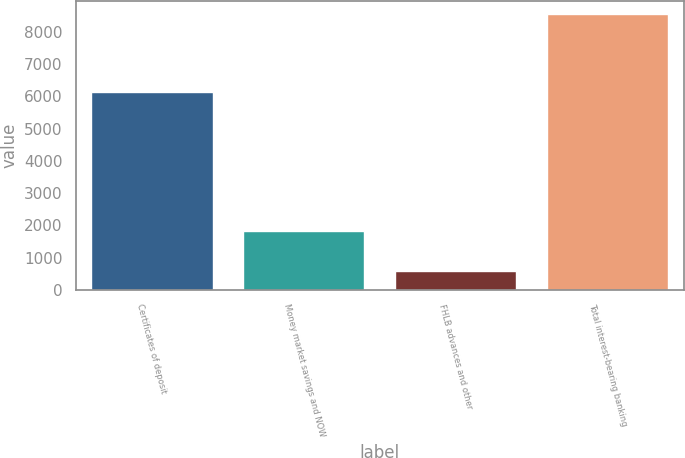<chart> <loc_0><loc_0><loc_500><loc_500><bar_chart><fcel>Certificates of deposit<fcel>Money market savings and NOW<fcel>FHLB advances and other<fcel>Total interest-bearing banking<nl><fcel>6126<fcel>1833<fcel>588<fcel>8547<nl></chart> 